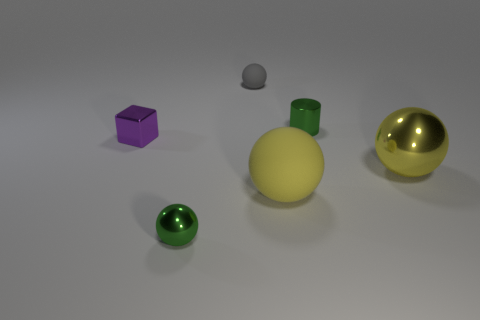What size is the gray rubber ball?
Offer a terse response. Small. Do the green metal thing that is in front of the cube and the matte sphere in front of the cylinder have the same size?
Your answer should be very brief. No. What size is the green metal thing that is the same shape as the yellow matte object?
Offer a very short reply. Small. There is a cube; does it have the same size as the yellow object that is left of the large yellow metallic thing?
Keep it short and to the point. No. Is there a large matte sphere left of the sphere behind the green shiny cylinder?
Give a very brief answer. No. The gray object that is behind the green metal sphere has what shape?
Give a very brief answer. Sphere. What material is the object that is the same color as the big matte ball?
Your response must be concise. Metal. What is the color of the shiny sphere that is behind the tiny ball that is in front of the small gray matte object?
Provide a short and direct response. Yellow. Do the gray rubber sphere and the yellow matte object have the same size?
Offer a very short reply. No. There is another tiny thing that is the same shape as the small rubber object; what is it made of?
Offer a very short reply. Metal. 